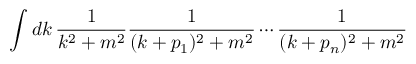<formula> <loc_0><loc_0><loc_500><loc_500>\int d k \, { \frac { 1 } { k ^ { 2 } + m ^ { 2 } } } { \frac { 1 } { ( k + p _ { 1 } ) ^ { 2 } + m ^ { 2 } } } \cdots { \frac { 1 } { ( k + p _ { n } ) ^ { 2 } + m ^ { 2 } } }</formula> 